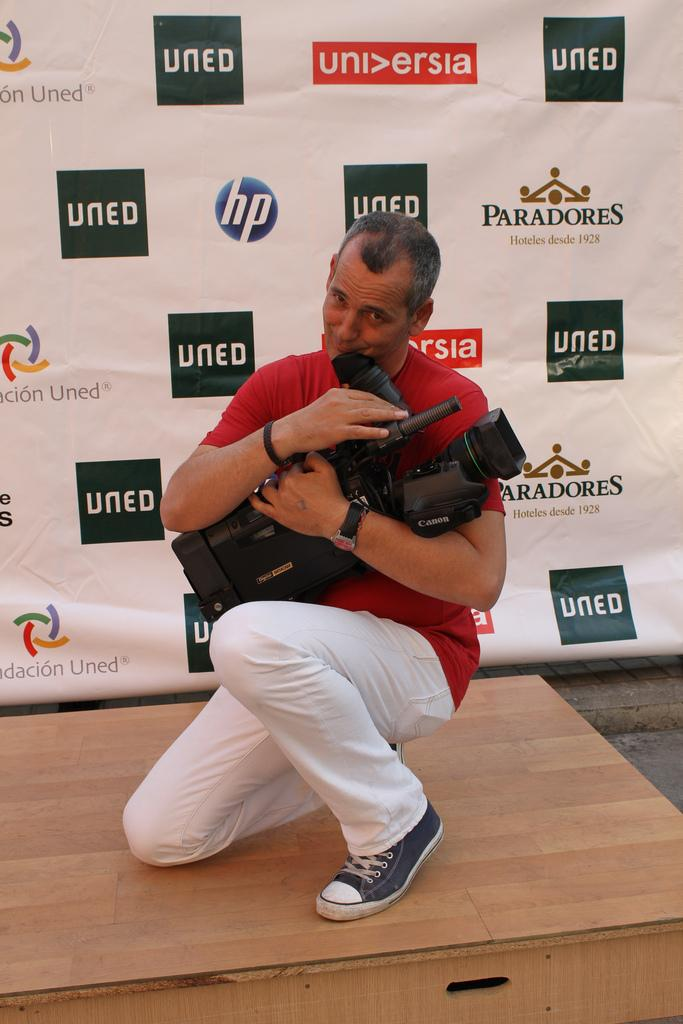<image>
Relay a brief, clear account of the picture shown. A man holds his camera lovingly as he stands in front of a wall with "uned" all over it. 